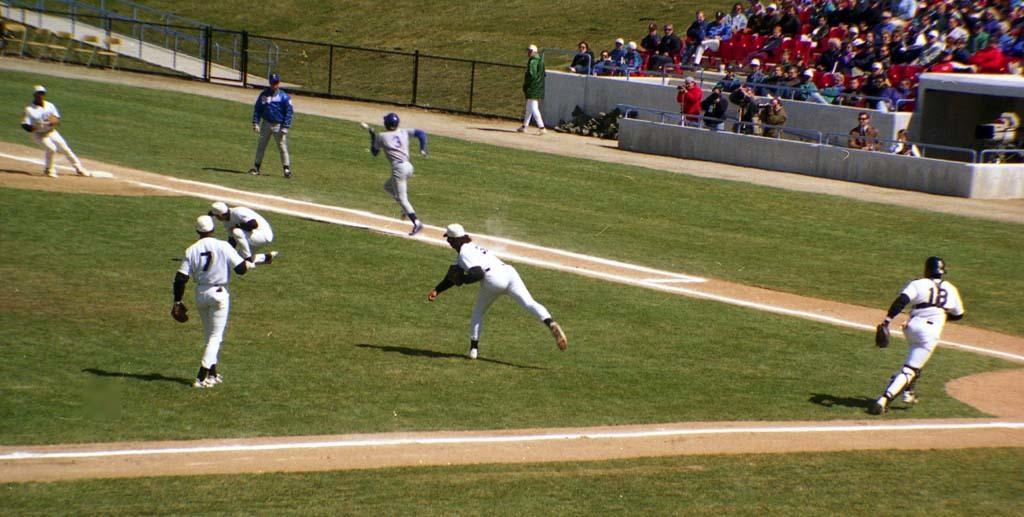Please provide a concise description of this image. In this image, we can see sports persons on the ground and in the background, there is a fence and we can see railings, some objects and there is a crowd. 